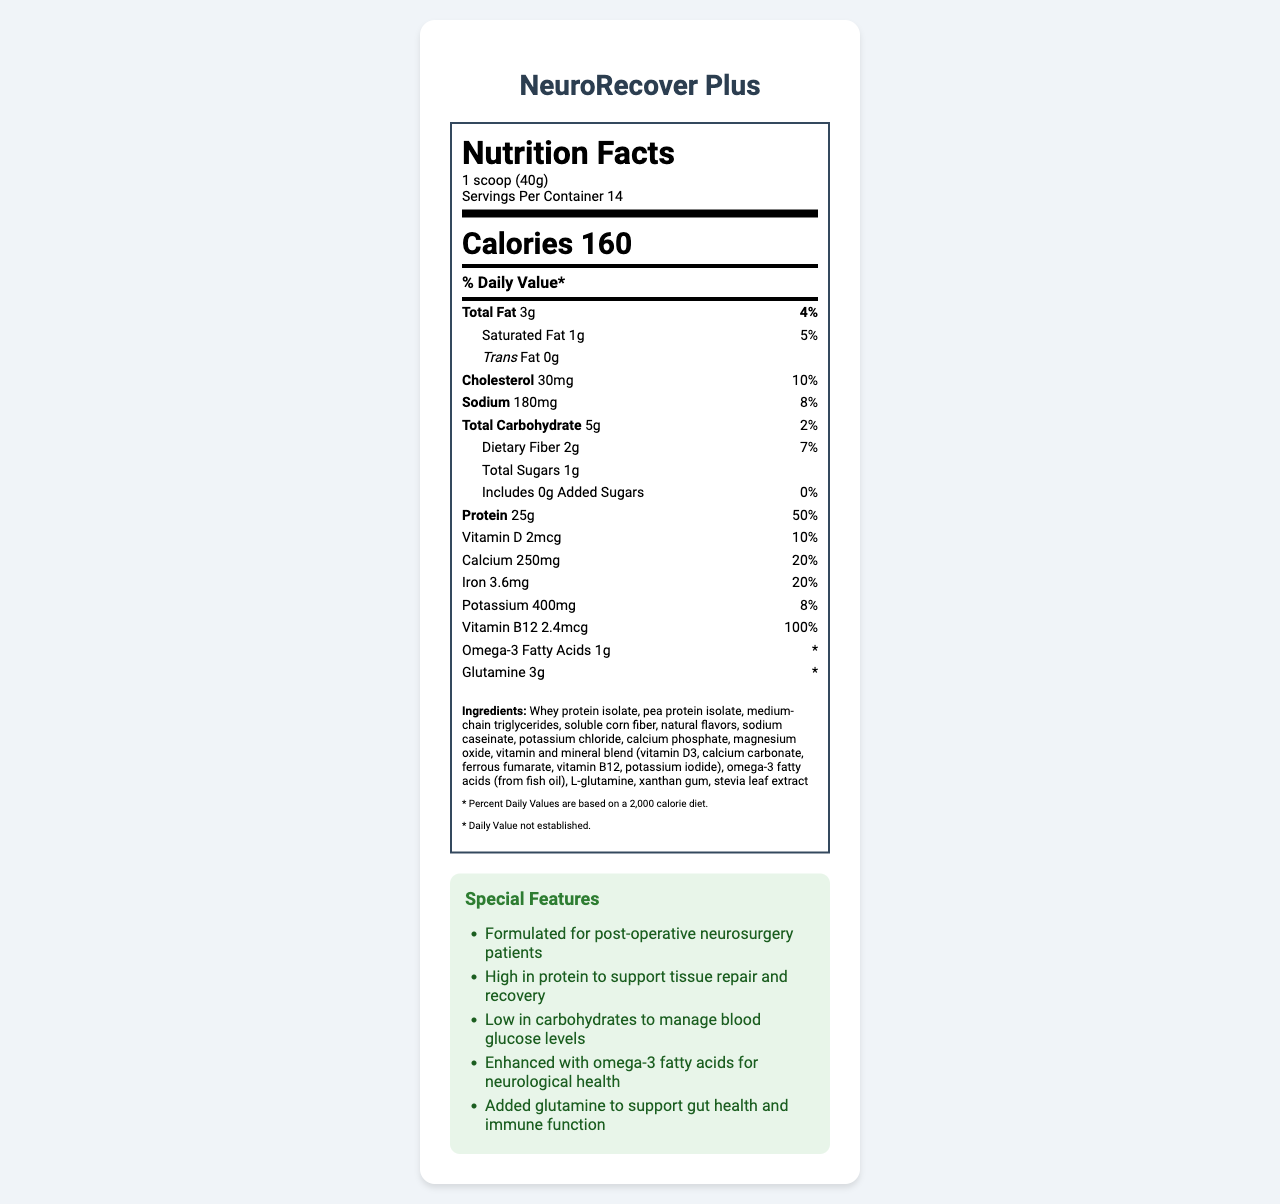what is the serving size for NeuroRecover Plus? The serving size is listed as "1 scoop (40g)" in the serving information section of the nutrition label.
Answer: 1 scoop (40g) How many servings are there per container? The nutrition label states that there are 14 servings per container.
Answer: 14 How much protein is in one serving? The protein content is indicated as "25g" under the protein section of the nutrition facts.
Answer: 25g How many calories does one serving provide? The calories per serving are listed as "160" near the top of the nutrition label.
Answer: 160 How much saturated fat is in one serving? The saturated fat content is stated as "1g" in the relevant section of the nutrition label.
Answer: 1g What is the percentage daily value of vitamin B12 per serving? The percentage daily value of vitamin B12 per serving is given as "100%".
Answer: 100% Which of the following is not an ingredient in NeuroRecover Plus? A. Whey protein isolate B. Corn syrup C. L-glutamine D. Stevia leaf extract The ingredients list does not include corn syrup, but it does include whey protein isolate, L-glutamine, and stevia leaf extract.
Answer: B. Corn syrup How much dietary fiber does one serving contain? The dietary fiber content is listed as "2g" in the nutrition facts.
Answer: 2g What special feature is associated with glutamine in this product? A. Supports tissue repair B. Supports gut health and immune function C. Manages blood glucose levels D. Enhances neurological health The special features section mentions that added glutamine supports gut health and immune function.
Answer: B. Supports gut health and immune function Does the product contain added sugars? The added sugars amount is listed as "0g" under the total sugars section, indicating there are no added sugars.
Answer: No Is this product designed specifically for post-operative neurosurgery patients? The product's special features state that it is formulated for post-operative neurosurgery patients.
Answer: Yes Summarize the main features and nutritional aspects of NeuroRecover Plus. This summary covers the nutritional facts, special features, allergens, and storage instructions provided on the nutrition label.
Answer: NeuroRecover Plus is a meal replacement shake designed for post-operative neurosurgery patients. It provides 160 calories per serving, with high protein content (25g), low carbs (5g), and beneficial nutrients, including omega-3 fatty acids and glutamine. Each serving contains 3g of total fat, 1g of saturated fat, and no trans fat or added sugars. It is enriched with essential vitamins and minerals such as vitamin D, calcium, iron, potassium, and vitamin B12. The product contains milk and fish and is produced in a facility that processes other allergens. It supports tissue repair, neurological health, and gut and immune function, making it suitable for post-operative recovery. What specific benefits does the high protein content of NeuroRecover Plus provide for neurosurgery patients? The document does not provide specific details on the benefits of high protein content for neurosurgery patients; it only states that high protein supports tissue repair and recovery.
Answer: Not enough information 